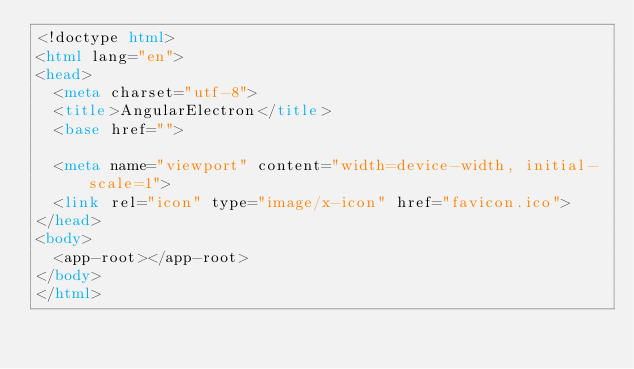<code> <loc_0><loc_0><loc_500><loc_500><_HTML_><!doctype html>
<html lang="en">
<head>
  <meta charset="utf-8">
  <title>AngularElectron</title>
  <base href="">

  <meta name="viewport" content="width=device-width, initial-scale=1">
  <link rel="icon" type="image/x-icon" href="favicon.ico">
</head>
<body>
  <app-root></app-root>
</body>
</html>
</code> 